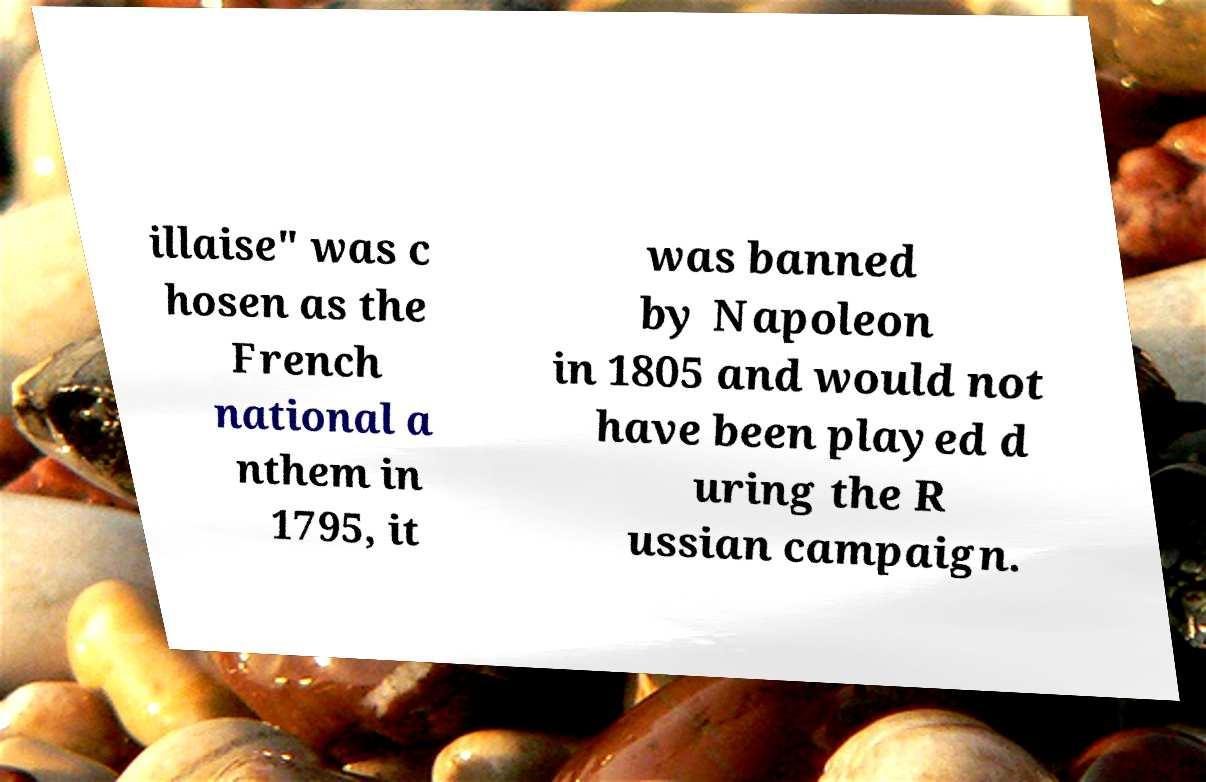For documentation purposes, I need the text within this image transcribed. Could you provide that? illaise" was c hosen as the French national a nthem in 1795, it was banned by Napoleon in 1805 and would not have been played d uring the R ussian campaign. 